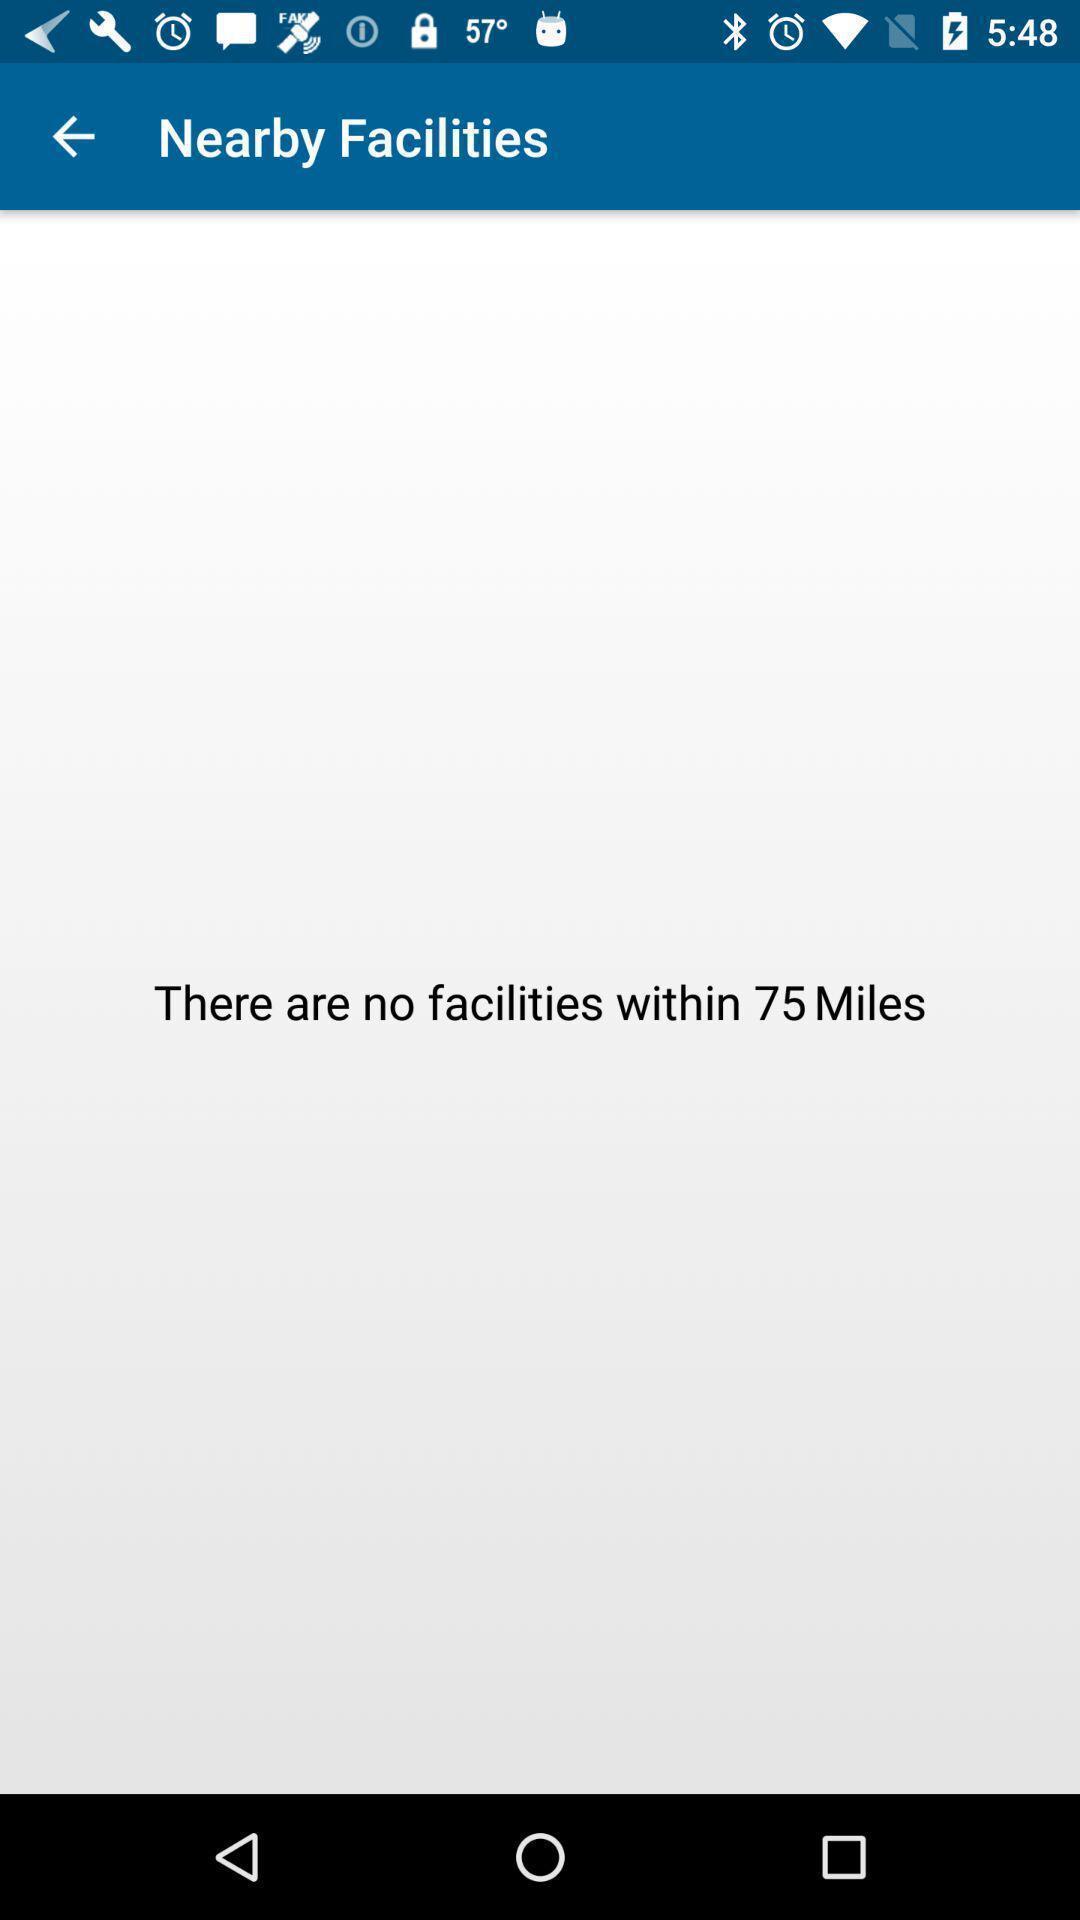Describe the content in this image. Result page showing a message. 